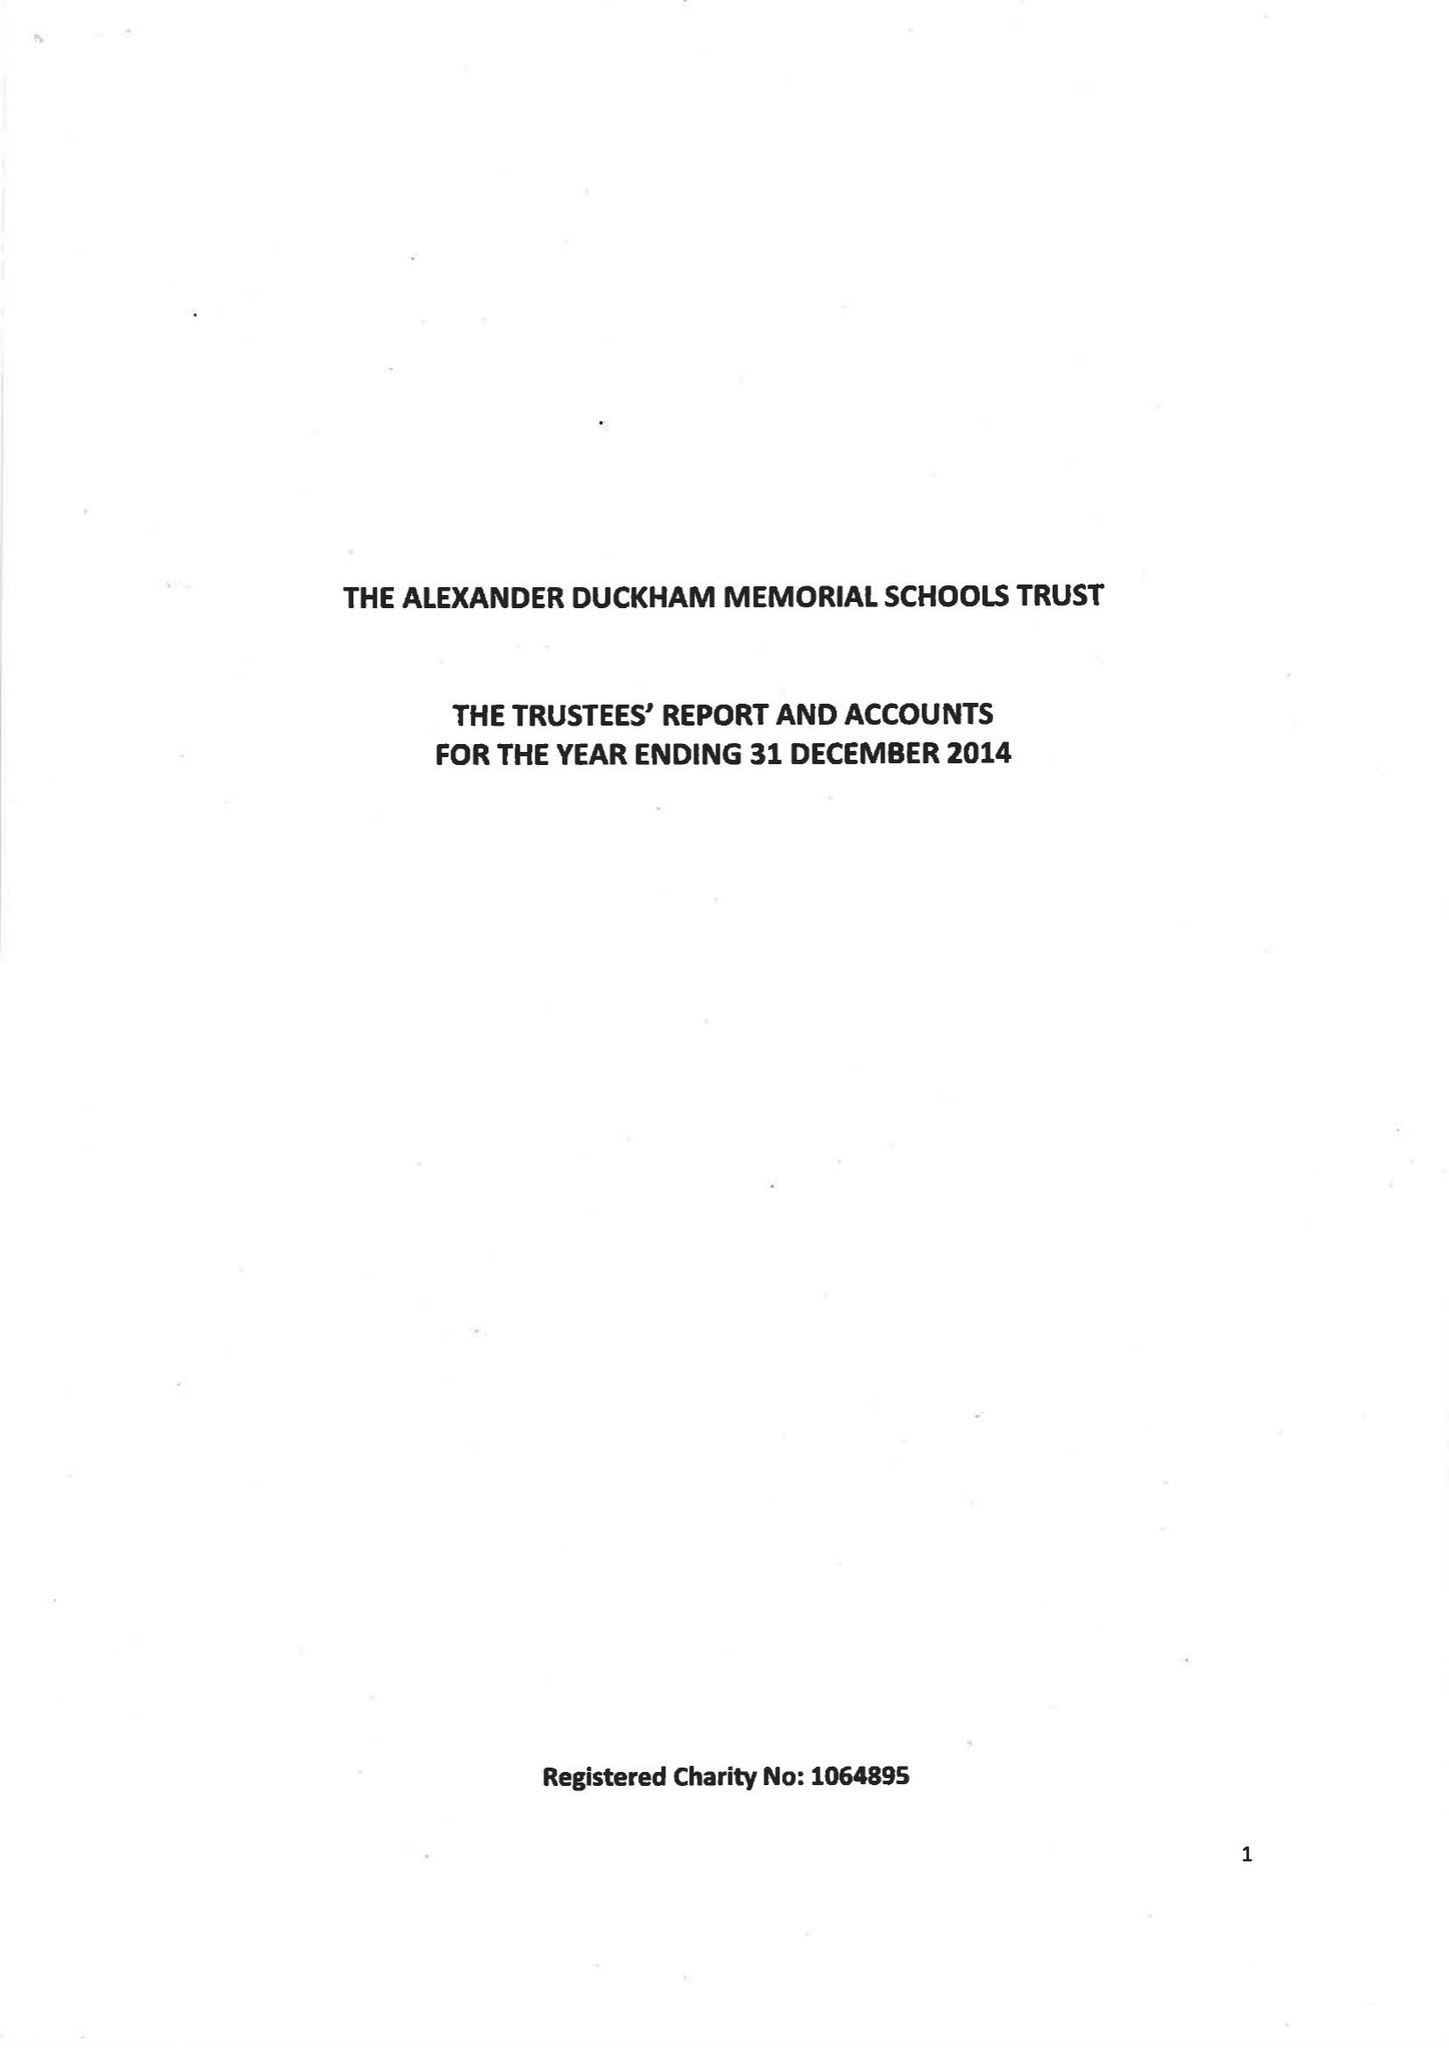What is the value for the charity_number?
Answer the question using a single word or phrase. 1064895 